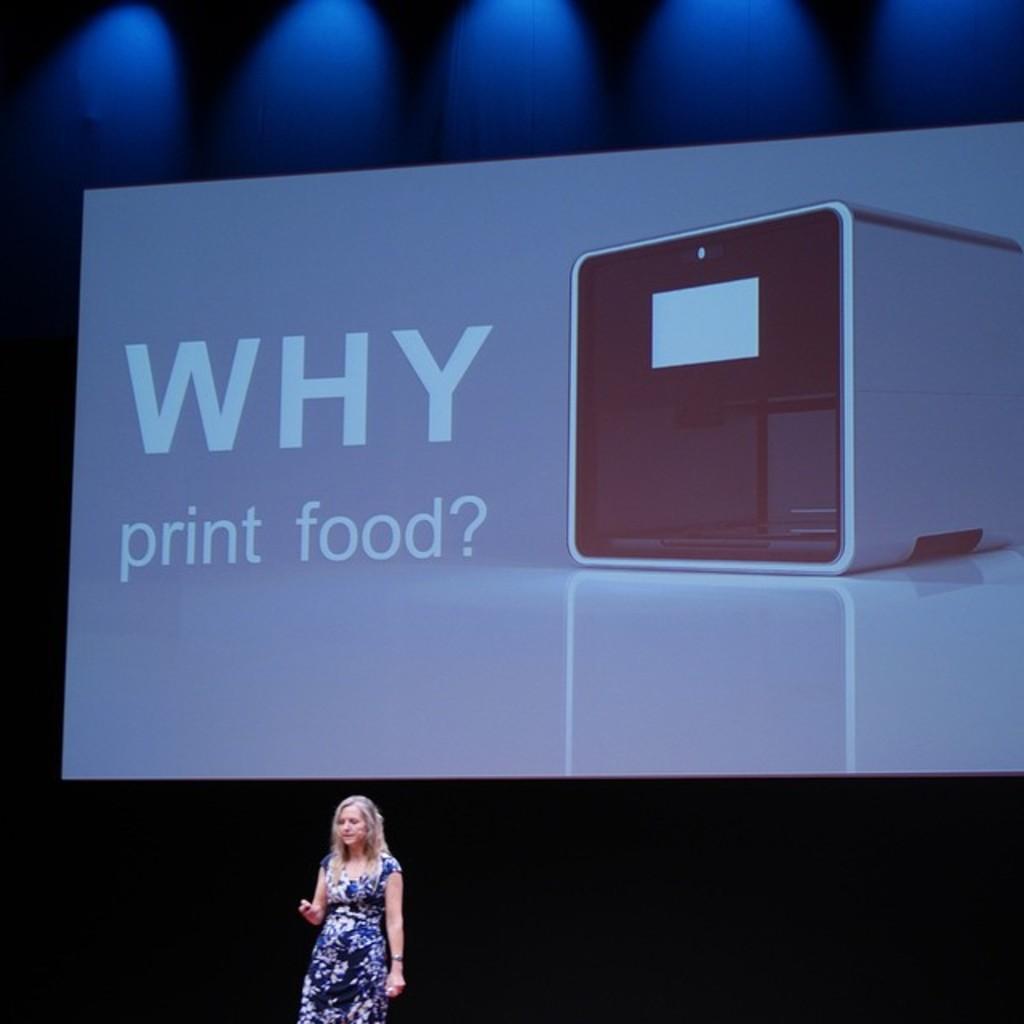Could you give a brief overview of what you see in this image? In the picture we can see a woman standing and giving a seminar and she is with blue dress and some designs on it and behind her we can see a screen on it we can see Why print food? And on the top of it, we can see blue color lights. 